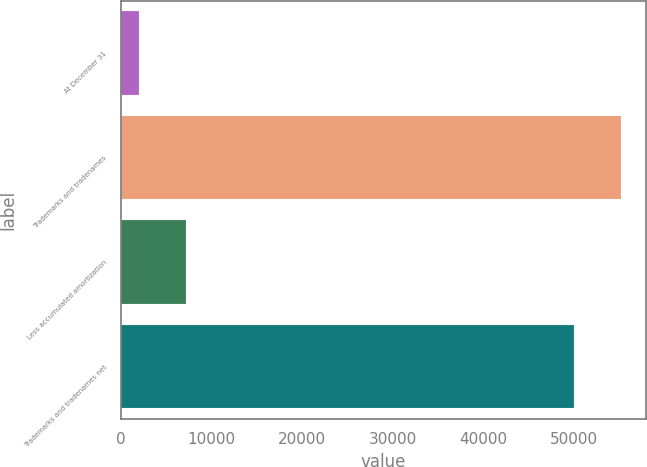Convert chart to OTSL. <chart><loc_0><loc_0><loc_500><loc_500><bar_chart><fcel>At December 31<fcel>Trademarks and tradenames<fcel>Less accumulated amortization<fcel>Trademarks and tradenames net<nl><fcel>2017<fcel>55151.2<fcel>7170.2<fcel>49998<nl></chart> 